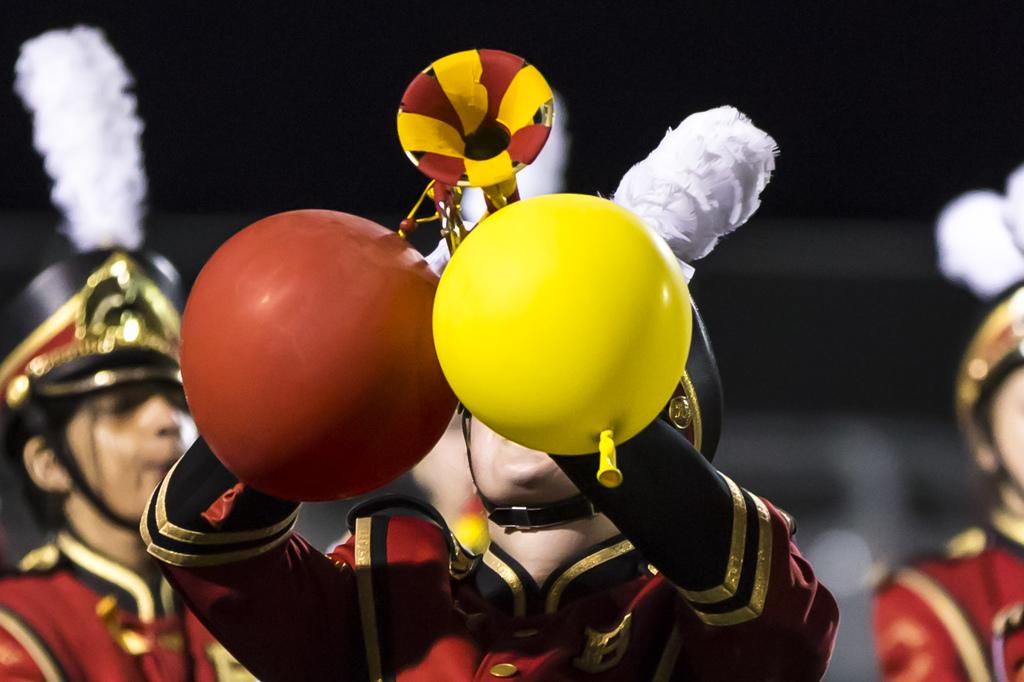How many people are in the image? There are persons in the image. What are the people in the image doing? One person is playing a musical instrument. Can you describe the background of the image? The background of the image is blurred. What type of alarm can be heard going off in the image? There is no alarm present in the image, and therefore no sound can be heard. 